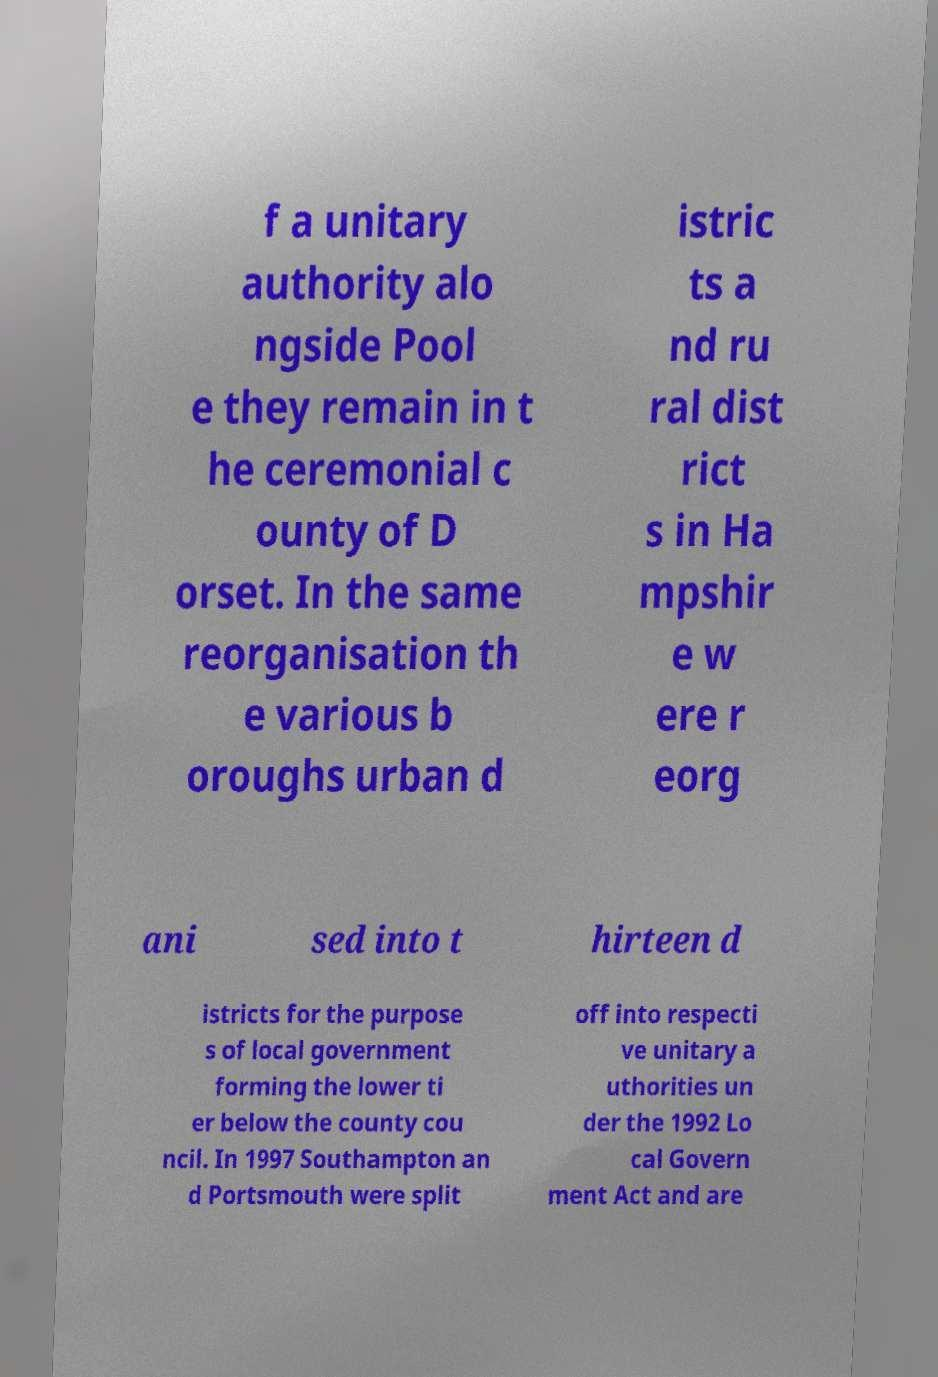Can you accurately transcribe the text from the provided image for me? f a unitary authority alo ngside Pool e they remain in t he ceremonial c ounty of D orset. In the same reorganisation th e various b oroughs urban d istric ts a nd ru ral dist rict s in Ha mpshir e w ere r eorg ani sed into t hirteen d istricts for the purpose s of local government forming the lower ti er below the county cou ncil. In 1997 Southampton an d Portsmouth were split off into respecti ve unitary a uthorities un der the 1992 Lo cal Govern ment Act and are 